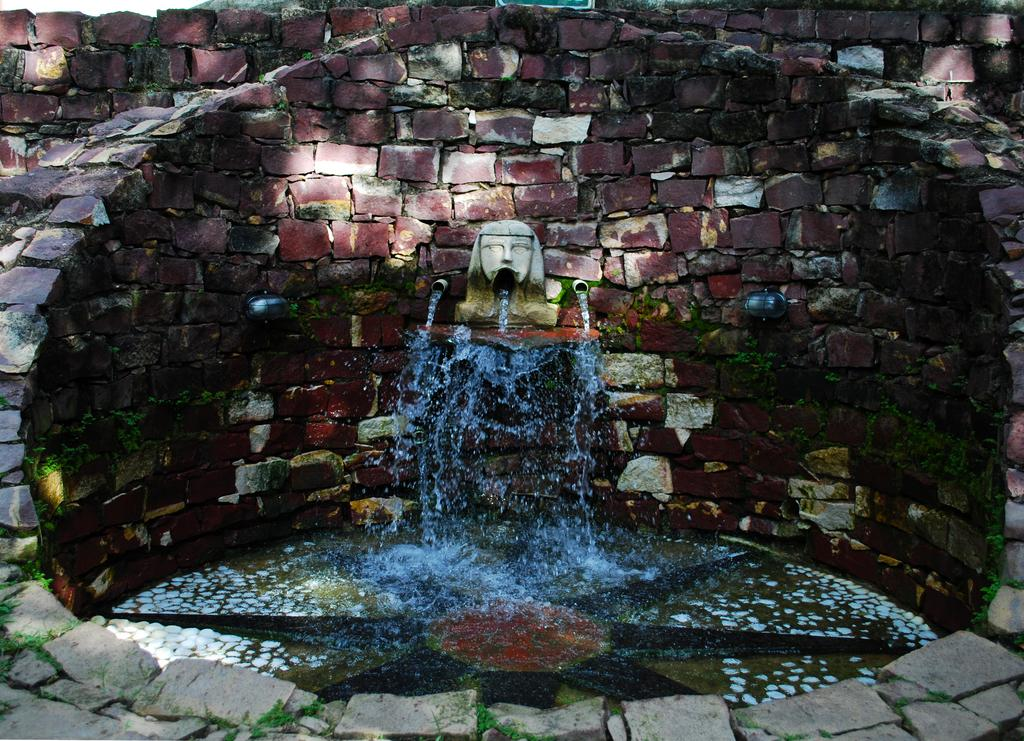What is the primary element in the image? There is water in the image. What other objects or features can be seen in the image? There are rocks in the image. What type of vegetation is visible at the bottom of the image? Grass is visible at the bottom of the image. What type of butter is being used to create the songs in the image? There is no butter or songs present in the image; it features water, rocks, and grass. 